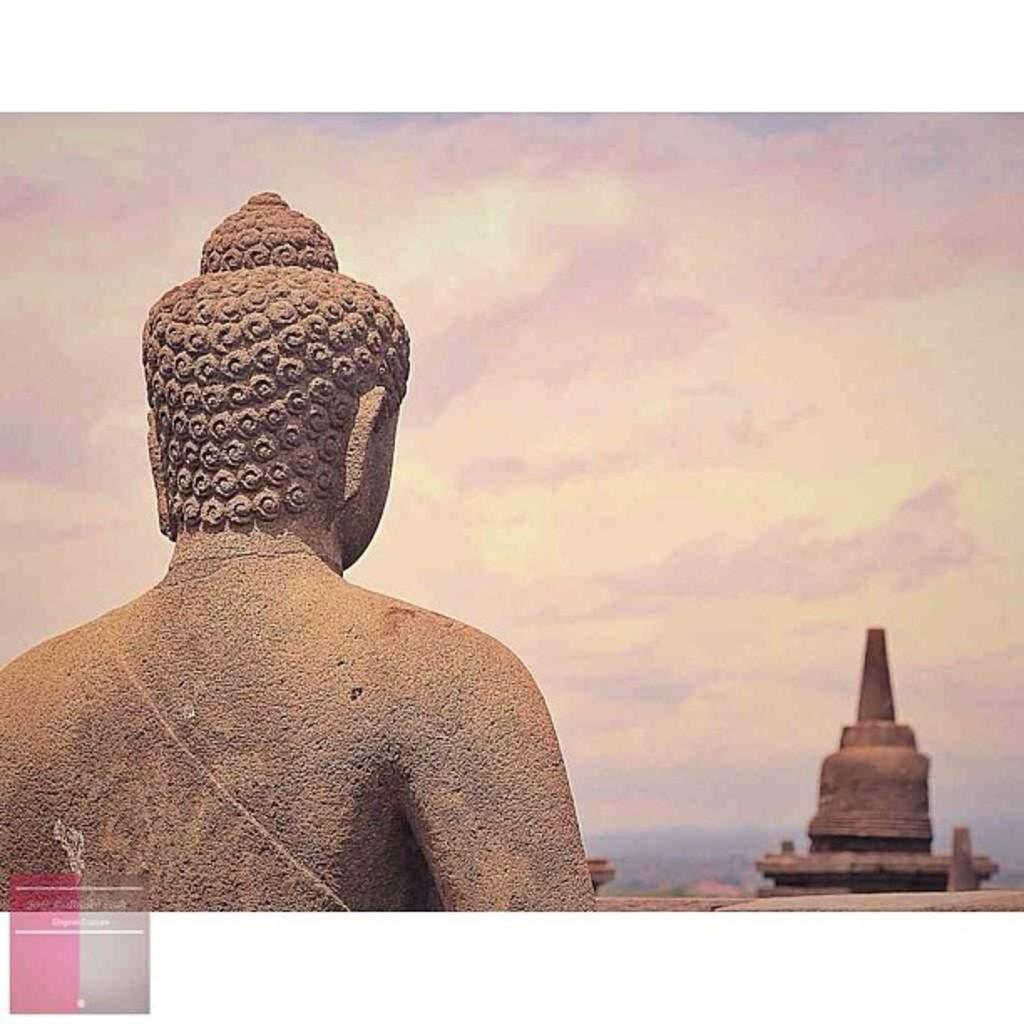In one or two sentences, can you explain what this image depicts? In this image, we can see a statue. Background there is a sky. Right side of the image, we can see an object. Left side bottom corner, there is a logo. 